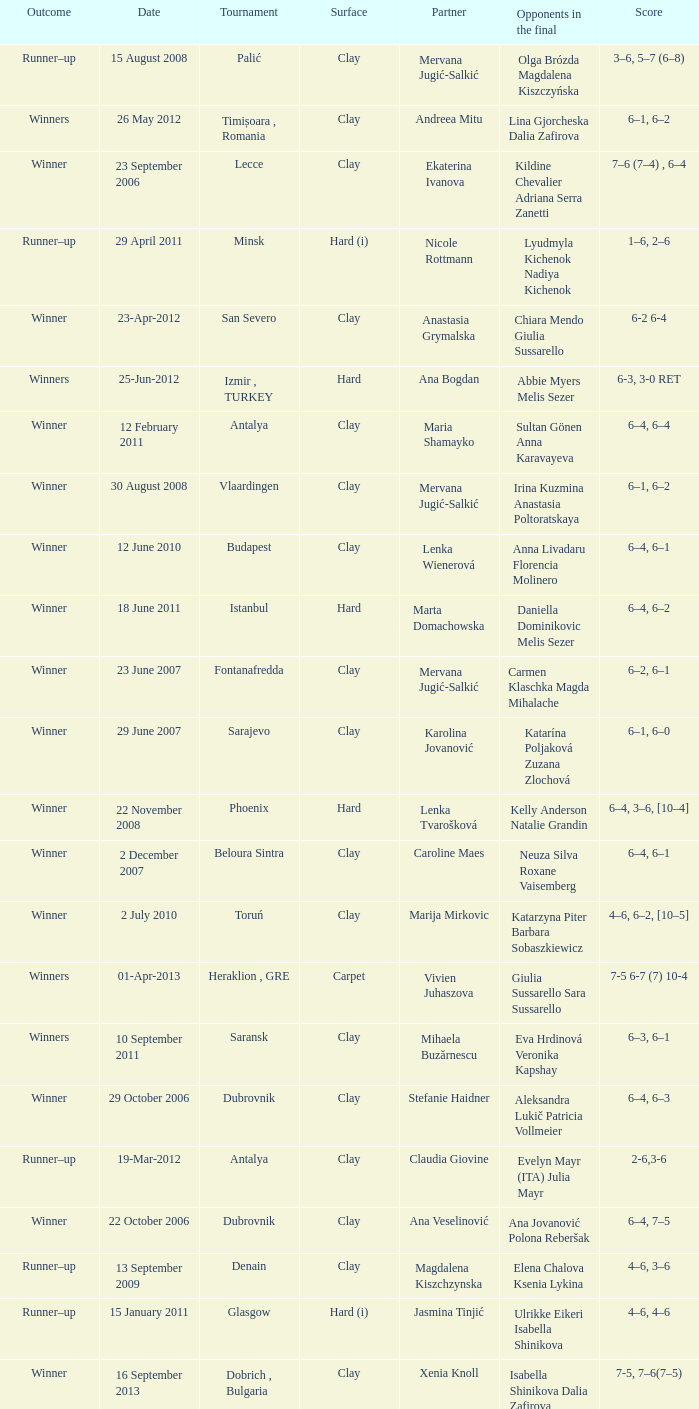Which tournament had a partner of Erika Sema? Aschaffenburg. 